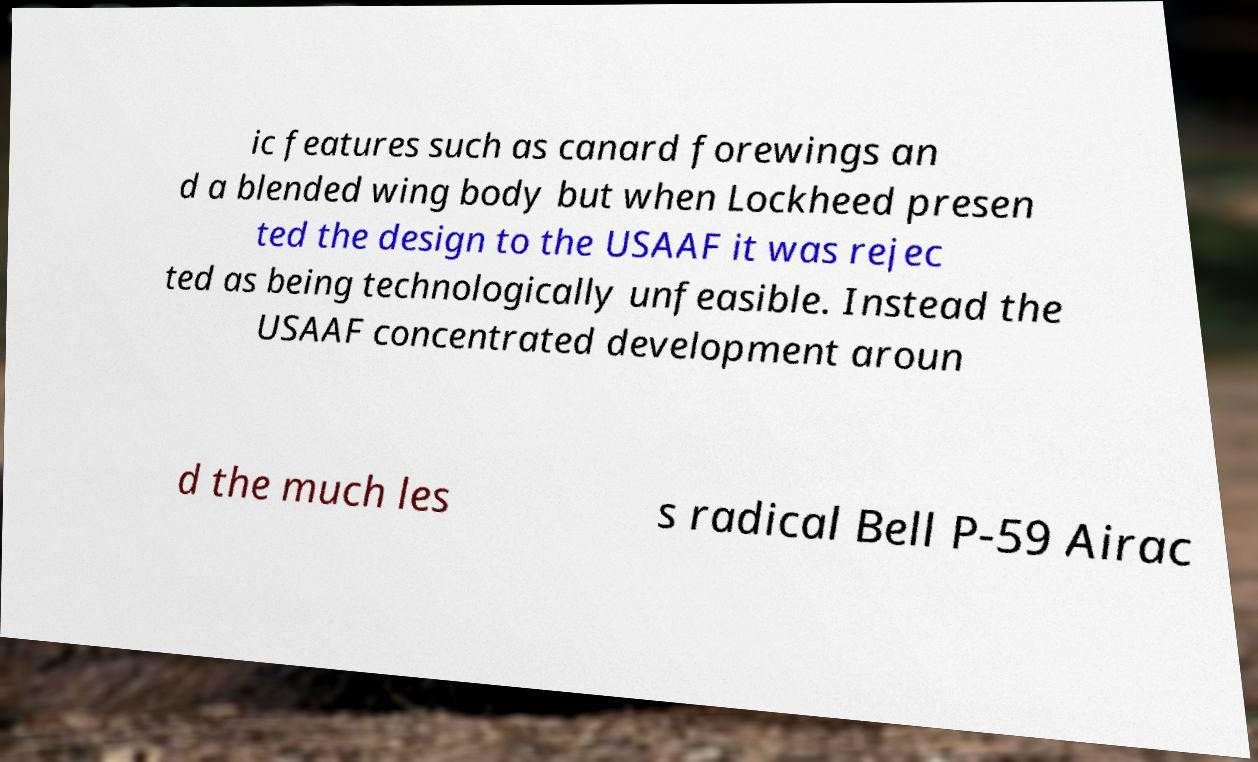What messages or text are displayed in this image? I need them in a readable, typed format. ic features such as canard forewings an d a blended wing body but when Lockheed presen ted the design to the USAAF it was rejec ted as being technologically unfeasible. Instead the USAAF concentrated development aroun d the much les s radical Bell P-59 Airac 